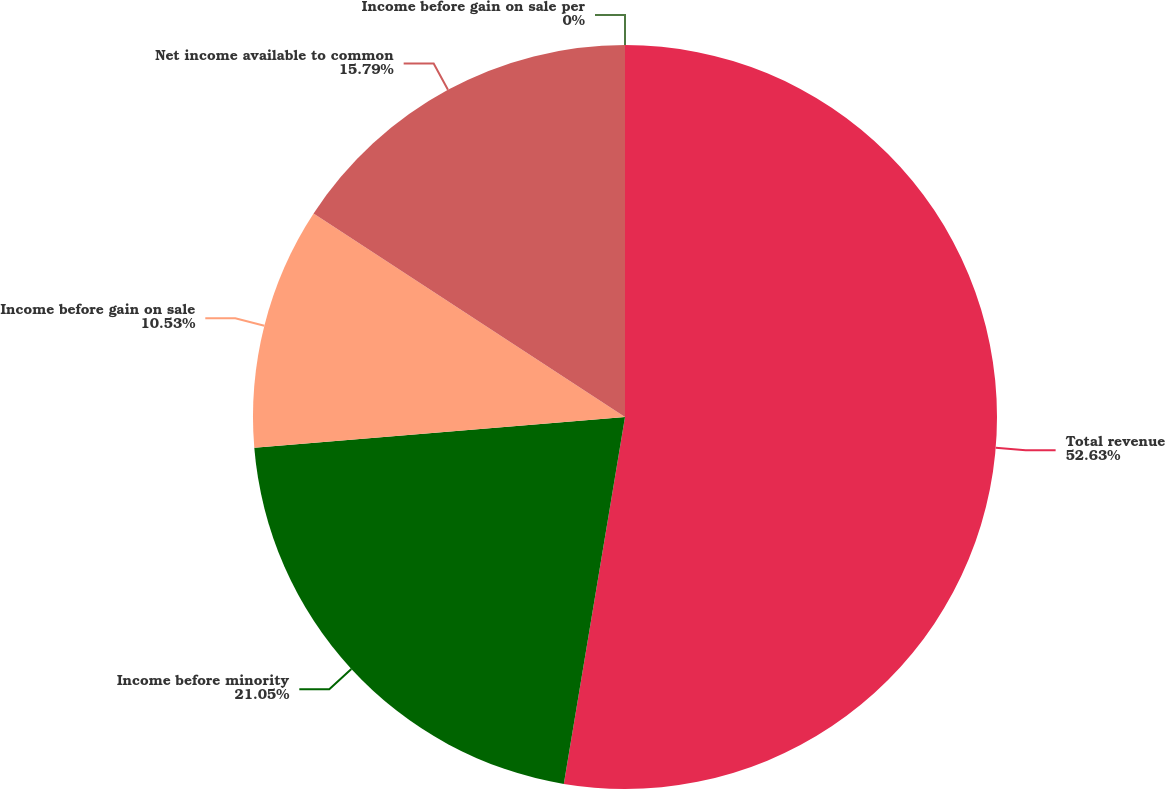Convert chart. <chart><loc_0><loc_0><loc_500><loc_500><pie_chart><fcel>Total revenue<fcel>Income before minority<fcel>Income before gain on sale<fcel>Net income available to common<fcel>Income before gain on sale per<nl><fcel>52.63%<fcel>21.05%<fcel>10.53%<fcel>15.79%<fcel>0.0%<nl></chart> 